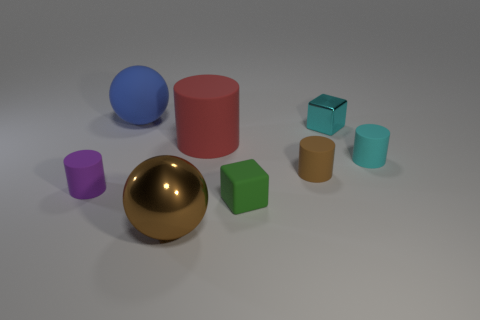There is a small rubber object that is on the left side of the large matte object to the left of the brown shiny thing; what is its shape?
Offer a terse response. Cylinder. What number of other things are the same color as the large rubber cylinder?
Ensure brevity in your answer.  0. Does the brown object that is in front of the small green rubber object have the same material as the cyan cylinder in front of the big blue matte sphere?
Provide a short and direct response. No. There is a sphere right of the big blue ball; what is its size?
Give a very brief answer. Large. What material is the other object that is the same shape as the brown metallic object?
Make the answer very short. Rubber. There is a large object that is in front of the tiny cyan cylinder; what shape is it?
Your response must be concise. Sphere. How many tiny red objects are the same shape as the purple object?
Your answer should be compact. 0. Are there an equal number of tiny cyan rubber cylinders in front of the purple matte cylinder and large matte cylinders left of the big red matte cylinder?
Ensure brevity in your answer.  Yes. Are there any small cyan cubes made of the same material as the brown sphere?
Make the answer very short. Yes. Do the big brown sphere and the big blue object have the same material?
Your answer should be compact. No. 